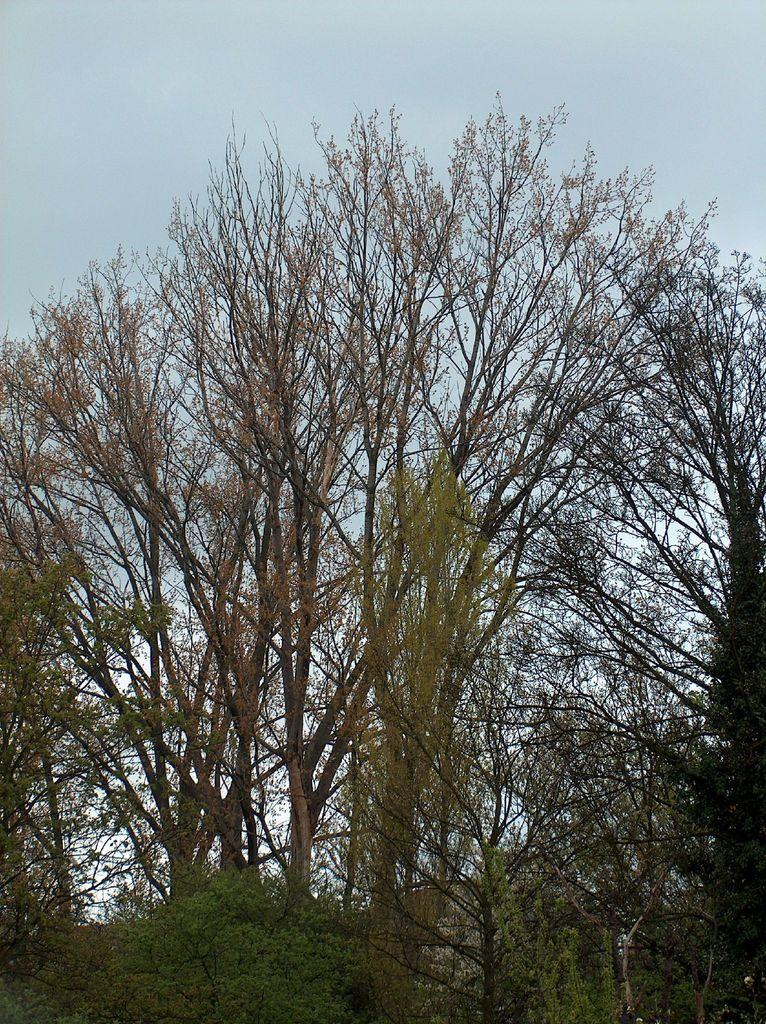What type of vegetation can be seen in the image? There are trees in the image. What is visible in the background of the image? The sky is visible in the background of the image. What type of vegetable is growing on the trees in the image? There are no vegetables growing on the trees in the image; the trees are not specified as fruit-bearing trees. 